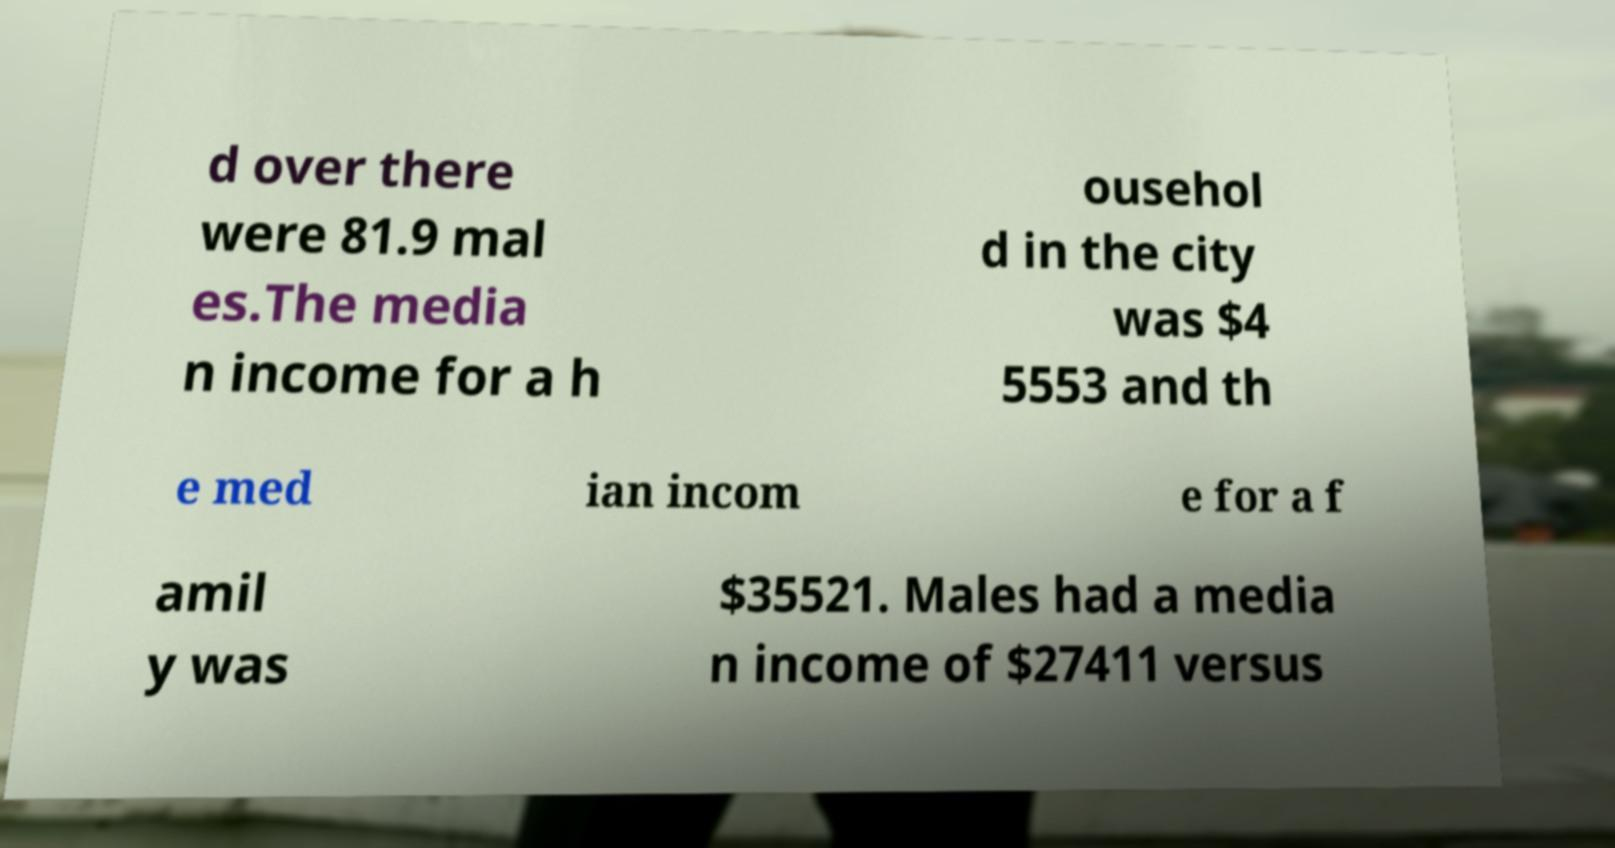Please read and relay the text visible in this image. What does it say? d over there were 81.9 mal es.The media n income for a h ousehol d in the city was $4 5553 and th e med ian incom e for a f amil y was $35521. Males had a media n income of $27411 versus 